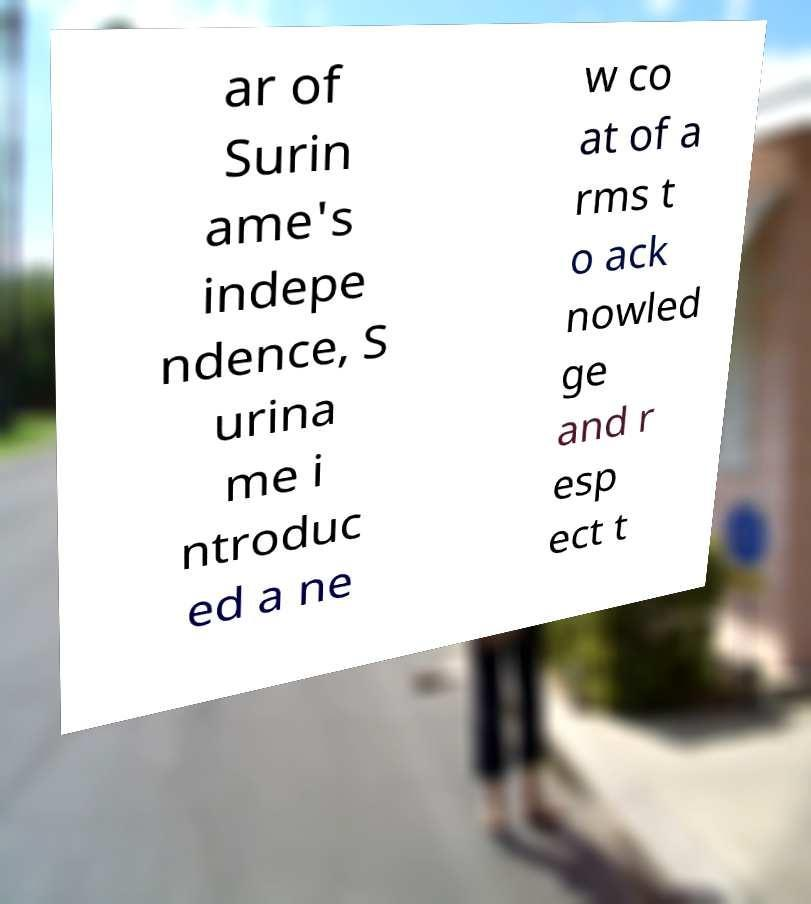Can you accurately transcribe the text from the provided image for me? ar of Surin ame's indepe ndence, S urina me i ntroduc ed a ne w co at of a rms t o ack nowled ge and r esp ect t 